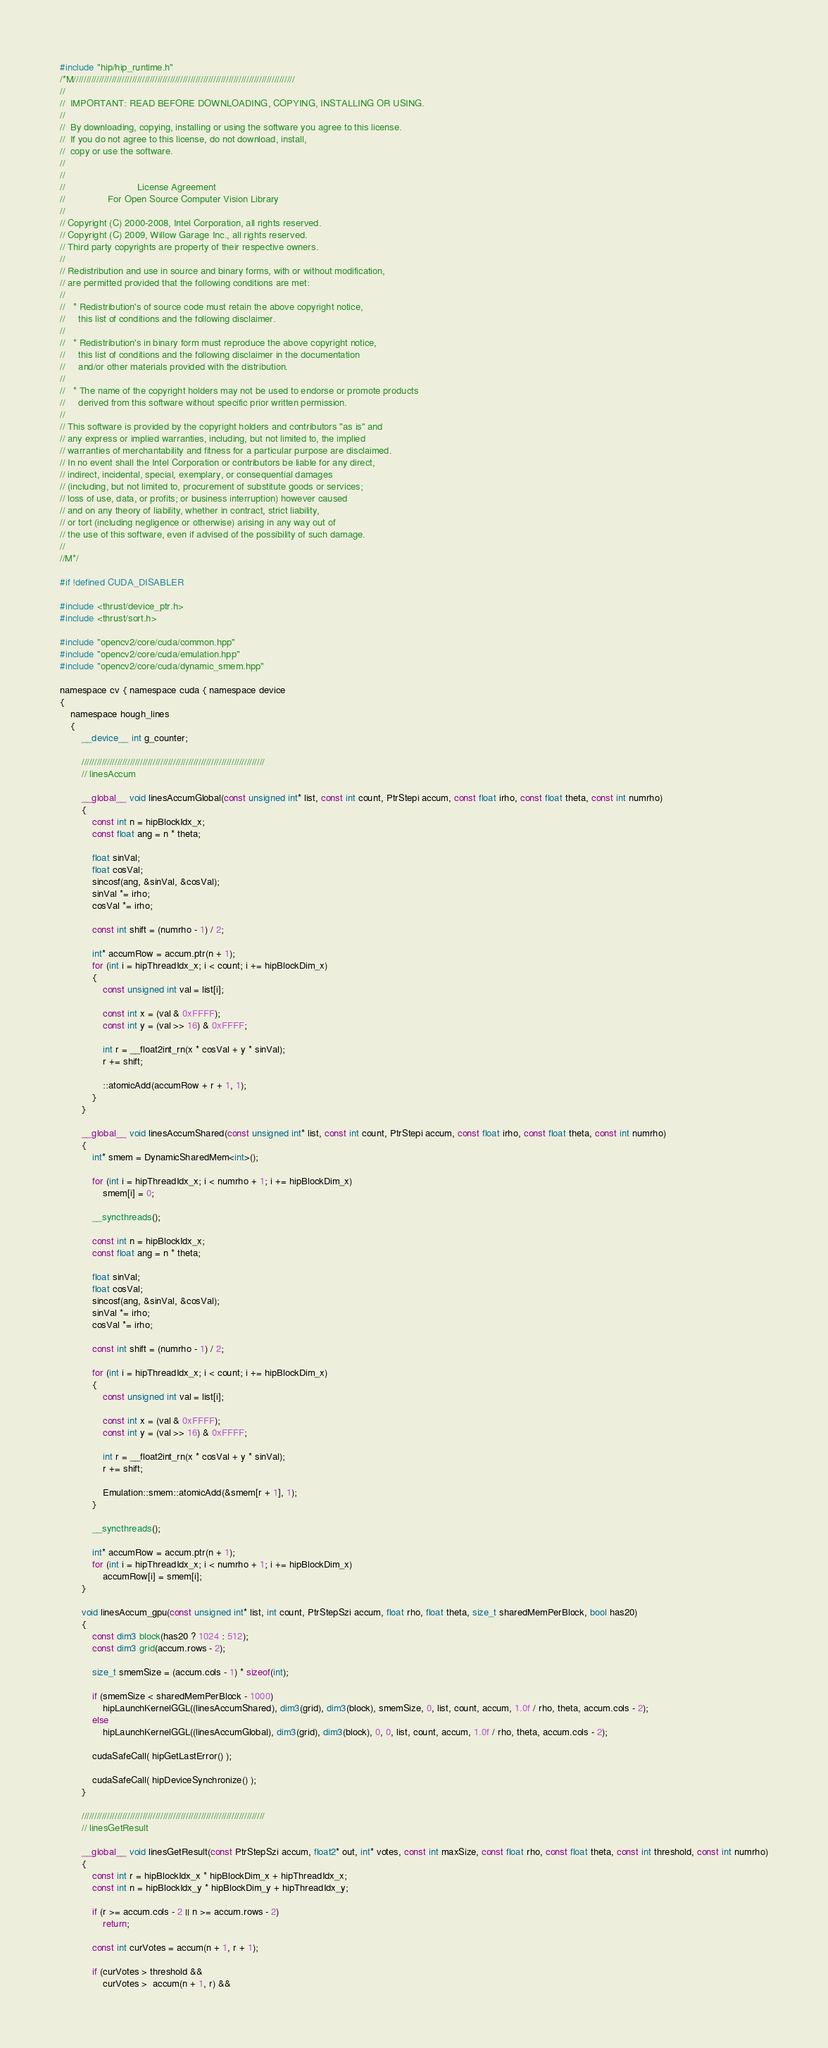Convert code to text. <code><loc_0><loc_0><loc_500><loc_500><_Cuda_>#include "hip/hip_runtime.h"
/*M///////////////////////////////////////////////////////////////////////////////////////
//
//  IMPORTANT: READ BEFORE DOWNLOADING, COPYING, INSTALLING OR USING.
//
//  By downloading, copying, installing or using the software you agree to this license.
//  If you do not agree to this license, do not download, install,
//  copy or use the software.
//
//
//                           License Agreement
//                For Open Source Computer Vision Library
//
// Copyright (C) 2000-2008, Intel Corporation, all rights reserved.
// Copyright (C) 2009, Willow Garage Inc., all rights reserved.
// Third party copyrights are property of their respective owners.
//
// Redistribution and use in source and binary forms, with or without modification,
// are permitted provided that the following conditions are met:
//
//   * Redistribution's of source code must retain the above copyright notice,
//     this list of conditions and the following disclaimer.
//
//   * Redistribution's in binary form must reproduce the above copyright notice,
//     this list of conditions and the following disclaimer in the documentation
//     and/or other materials provided with the distribution.
//
//   * The name of the copyright holders may not be used to endorse or promote products
//     derived from this software without specific prior written permission.
//
// This software is provided by the copyright holders and contributors "as is" and
// any express or implied warranties, including, but not limited to, the implied
// warranties of merchantability and fitness for a particular purpose are disclaimed.
// In no event shall the Intel Corporation or contributors be liable for any direct,
// indirect, incidental, special, exemplary, or consequential damages
// (including, but not limited to, procurement of substitute goods or services;
// loss of use, data, or profits; or business interruption) however caused
// and on any theory of liability, whether in contract, strict liability,
// or tort (including negligence or otherwise) arising in any way out of
// the use of this software, even if advised of the possibility of such damage.
//
//M*/

#if !defined CUDA_DISABLER

#include <thrust/device_ptr.h>
#include <thrust/sort.h>

#include "opencv2/core/cuda/common.hpp"
#include "opencv2/core/cuda/emulation.hpp"
#include "opencv2/core/cuda/dynamic_smem.hpp"

namespace cv { namespace cuda { namespace device
{
    namespace hough_lines
    {
        __device__ int g_counter;

        ////////////////////////////////////////////////////////////////////////
        // linesAccum

        __global__ void linesAccumGlobal(const unsigned int* list, const int count, PtrStepi accum, const float irho, const float theta, const int numrho)
        {
            const int n = hipBlockIdx_x;
            const float ang = n * theta;

            float sinVal;
            float cosVal;
            sincosf(ang, &sinVal, &cosVal);
            sinVal *= irho;
            cosVal *= irho;

            const int shift = (numrho - 1) / 2;

            int* accumRow = accum.ptr(n + 1);
            for (int i = hipThreadIdx_x; i < count; i += hipBlockDim_x)
            {
                const unsigned int val = list[i];

                const int x = (val & 0xFFFF);
                const int y = (val >> 16) & 0xFFFF;

                int r = __float2int_rn(x * cosVal + y * sinVal);
                r += shift;

                ::atomicAdd(accumRow + r + 1, 1);
            }
        }

        __global__ void linesAccumShared(const unsigned int* list, const int count, PtrStepi accum, const float irho, const float theta, const int numrho)
        {
            int* smem = DynamicSharedMem<int>();

            for (int i = hipThreadIdx_x; i < numrho + 1; i += hipBlockDim_x)
                smem[i] = 0;

            __syncthreads();

            const int n = hipBlockIdx_x;
            const float ang = n * theta;

            float sinVal;
            float cosVal;
            sincosf(ang, &sinVal, &cosVal);
            sinVal *= irho;
            cosVal *= irho;

            const int shift = (numrho - 1) / 2;

            for (int i = hipThreadIdx_x; i < count; i += hipBlockDim_x)
            {
                const unsigned int val = list[i];

                const int x = (val & 0xFFFF);
                const int y = (val >> 16) & 0xFFFF;

                int r = __float2int_rn(x * cosVal + y * sinVal);
                r += shift;

                Emulation::smem::atomicAdd(&smem[r + 1], 1);
            }

            __syncthreads();

            int* accumRow = accum.ptr(n + 1);
            for (int i = hipThreadIdx_x; i < numrho + 1; i += hipBlockDim_x)
                accumRow[i] = smem[i];
        }

        void linesAccum_gpu(const unsigned int* list, int count, PtrStepSzi accum, float rho, float theta, size_t sharedMemPerBlock, bool has20)
        {
            const dim3 block(has20 ? 1024 : 512);
            const dim3 grid(accum.rows - 2);

            size_t smemSize = (accum.cols - 1) * sizeof(int);

            if (smemSize < sharedMemPerBlock - 1000)
                hipLaunchKernelGGL((linesAccumShared), dim3(grid), dim3(block), smemSize, 0, list, count, accum, 1.0f / rho, theta, accum.cols - 2);
            else
                hipLaunchKernelGGL((linesAccumGlobal), dim3(grid), dim3(block), 0, 0, list, count, accum, 1.0f / rho, theta, accum.cols - 2);

            cudaSafeCall( hipGetLastError() );

            cudaSafeCall( hipDeviceSynchronize() );
        }

        ////////////////////////////////////////////////////////////////////////
        // linesGetResult

        __global__ void linesGetResult(const PtrStepSzi accum, float2* out, int* votes, const int maxSize, const float rho, const float theta, const int threshold, const int numrho)
        {
            const int r = hipBlockIdx_x * hipBlockDim_x + hipThreadIdx_x;
            const int n = hipBlockIdx_y * hipBlockDim_y + hipThreadIdx_y;

            if (r >= accum.cols - 2 || n >= accum.rows - 2)
                return;

            const int curVotes = accum(n + 1, r + 1);

            if (curVotes > threshold &&
                curVotes >  accum(n + 1, r) &&</code> 